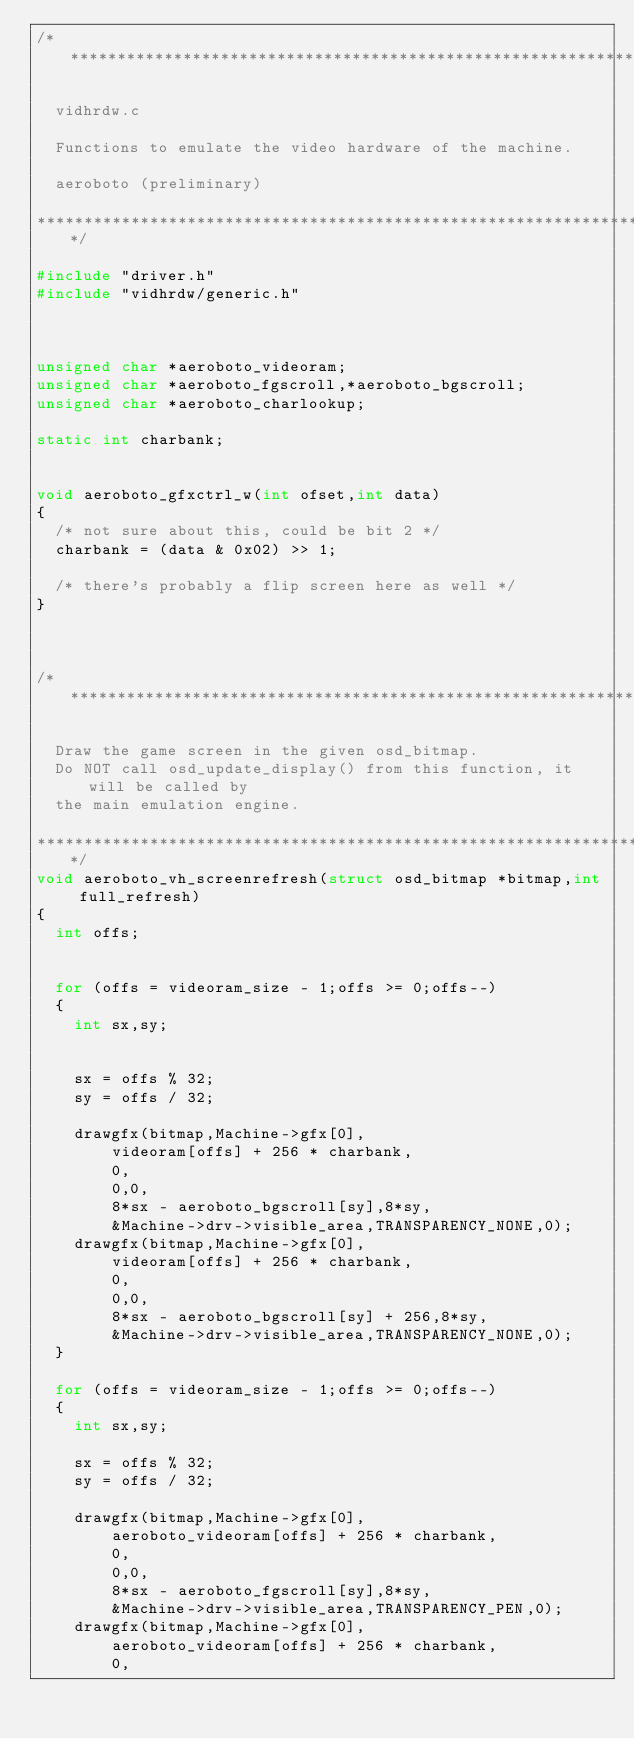Convert code to text. <code><loc_0><loc_0><loc_500><loc_500><_C++_>/***************************************************************************

  vidhrdw.c

  Functions to emulate the video hardware of the machine.

  aeroboto (preliminary)

***************************************************************************/

#include "driver.h"
#include "vidhrdw/generic.h"



unsigned char *aeroboto_videoram;
unsigned char *aeroboto_fgscroll,*aeroboto_bgscroll;
unsigned char *aeroboto_charlookup;

static int charbank;


void aeroboto_gfxctrl_w(int ofset,int data)
{
	/* not sure about this, could be bit 2 */
	charbank = (data & 0x02) >> 1;

	/* there's probably a flip screen here as well */
}



/***************************************************************************

  Draw the game screen in the given osd_bitmap.
  Do NOT call osd_update_display() from this function, it will be called by
  the main emulation engine.

***************************************************************************/
void aeroboto_vh_screenrefresh(struct osd_bitmap *bitmap,int full_refresh)
{
	int offs;


	for (offs = videoram_size - 1;offs >= 0;offs--)
	{
		int sx,sy;


		sx = offs % 32;
		sy = offs / 32;

		drawgfx(bitmap,Machine->gfx[0],
				videoram[offs] + 256 * charbank,
				0,
				0,0,
				8*sx - aeroboto_bgscroll[sy],8*sy,
				&Machine->drv->visible_area,TRANSPARENCY_NONE,0);
		drawgfx(bitmap,Machine->gfx[0],
				videoram[offs] + 256 * charbank,
				0,
				0,0,
				8*sx - aeroboto_bgscroll[sy] + 256,8*sy,
				&Machine->drv->visible_area,TRANSPARENCY_NONE,0);
	}

	for (offs = videoram_size - 1;offs >= 0;offs--)
	{
		int sx,sy;

		sx = offs % 32;
		sy = offs / 32;

		drawgfx(bitmap,Machine->gfx[0],
				aeroboto_videoram[offs] + 256 * charbank,
				0,
				0,0,
				8*sx - aeroboto_fgscroll[sy],8*sy,
				&Machine->drv->visible_area,TRANSPARENCY_PEN,0);
		drawgfx(bitmap,Machine->gfx[0],
				aeroboto_videoram[offs] + 256 * charbank,
				0,</code> 